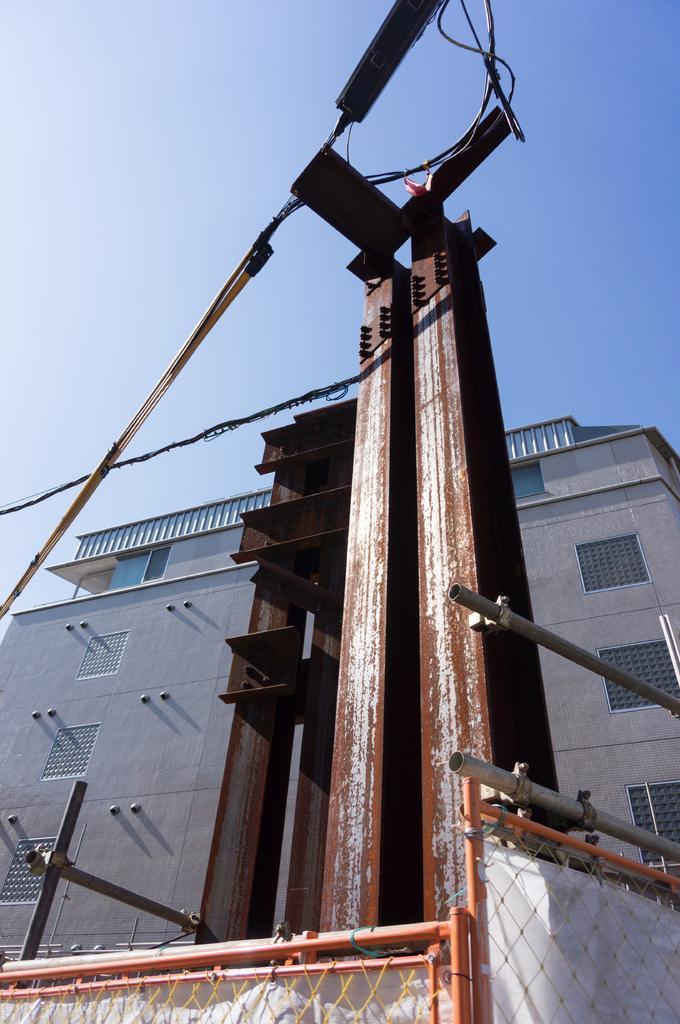How would you summarize this image in a sentence or two? In this image we can see a building. We can see few cables connected to a pole. We can see the sky in the image. We can see the barrier at the bottom of the image. 